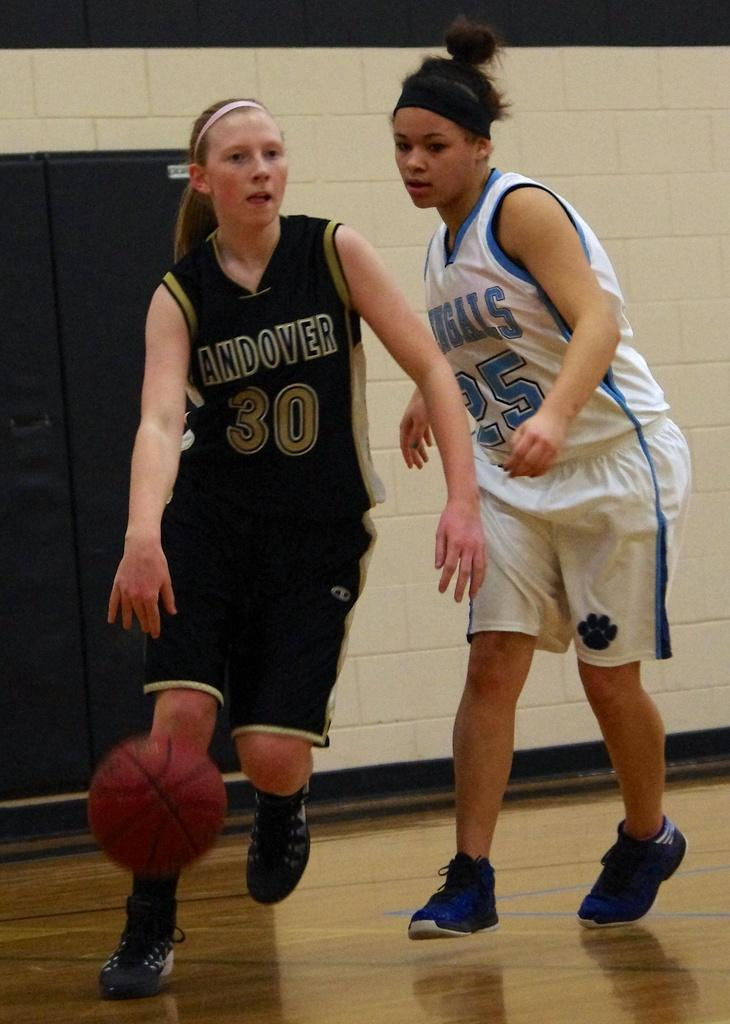<image>
Provide a brief description of the given image. the number 30 is on the jersey of a person 